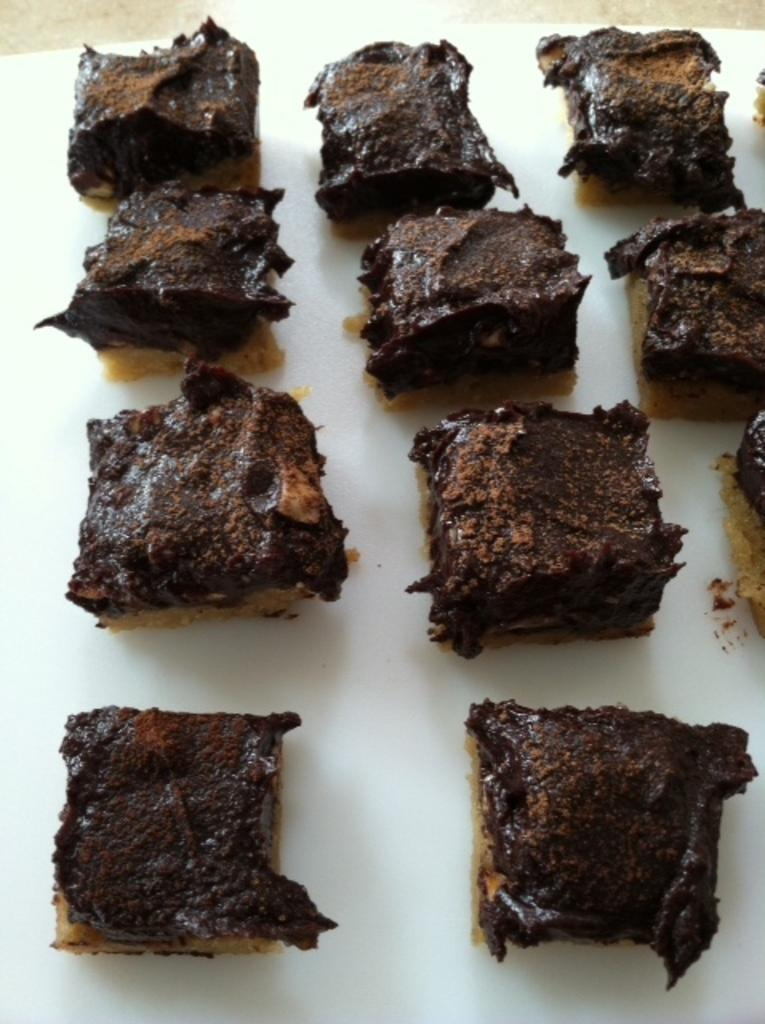What type of dessert is visible in the image? There are chocolate brownies in the image. What color is the surface on which the brownies are placed? The brownies are on a white color surface. What type of decision is being made by the lettuce in the image? There is no lettuce present in the image, so no decision can be made by it. 